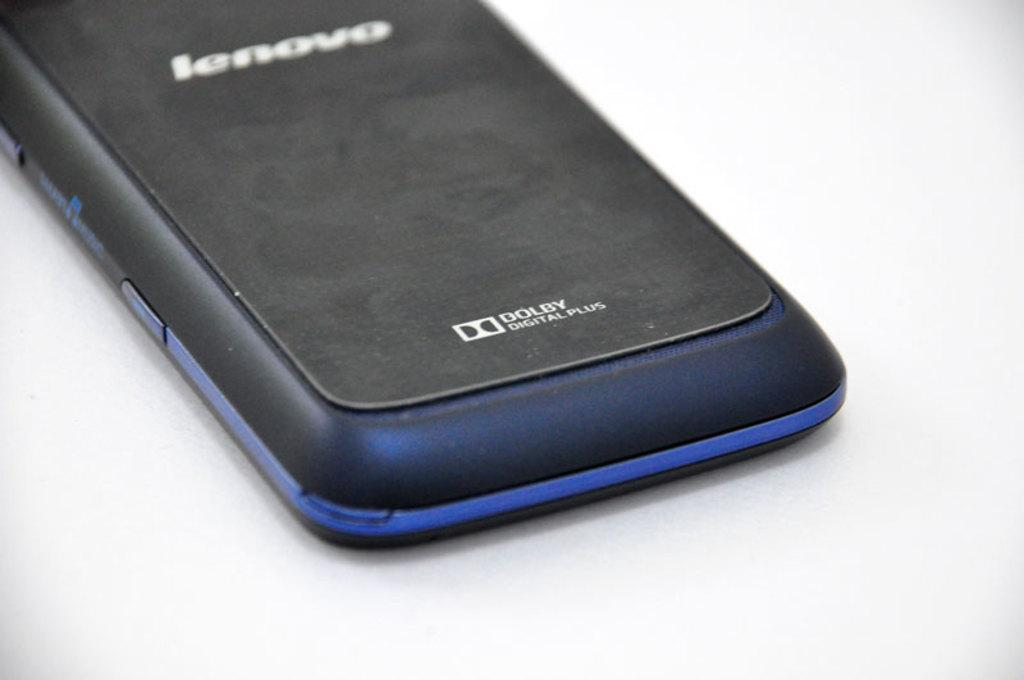<image>
Summarize the visual content of the image. back of a lenovo phone that features dolby digital plus 